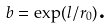<formula> <loc_0><loc_0><loc_500><loc_500>b = \exp ( l / r _ { 0 } ) \text {.}</formula> 